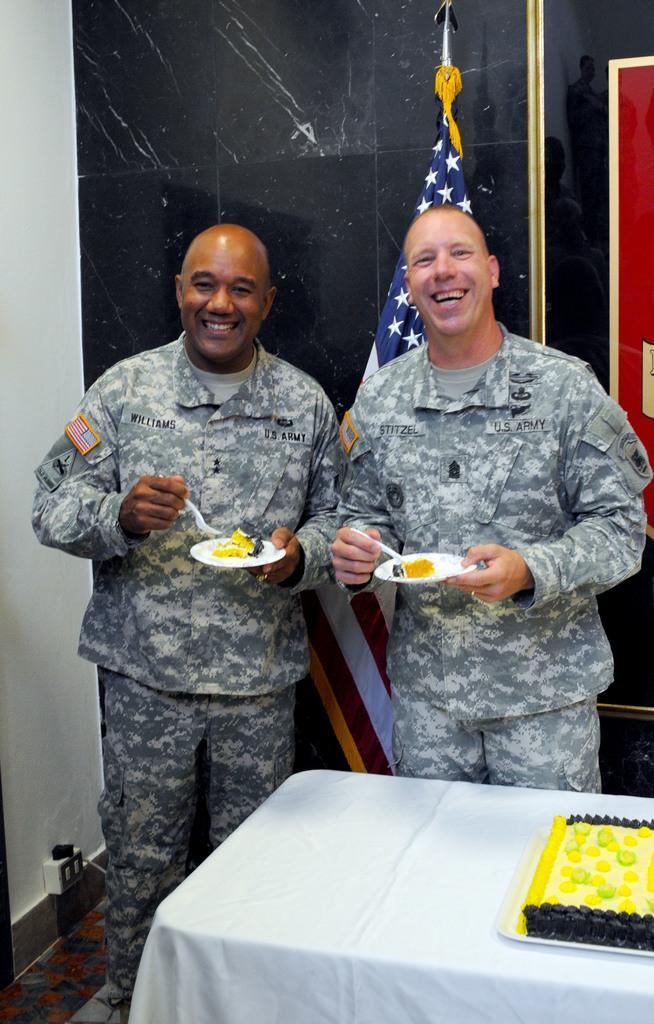Describe this image in one or two sentences. In the center of the picture we can see two persons holding plates, in the plates there is food item. The persons are laughing, behind them we can see a flag and wall. In the foreground there is a table, on the table there is a cake. On the left we can see a wall. 